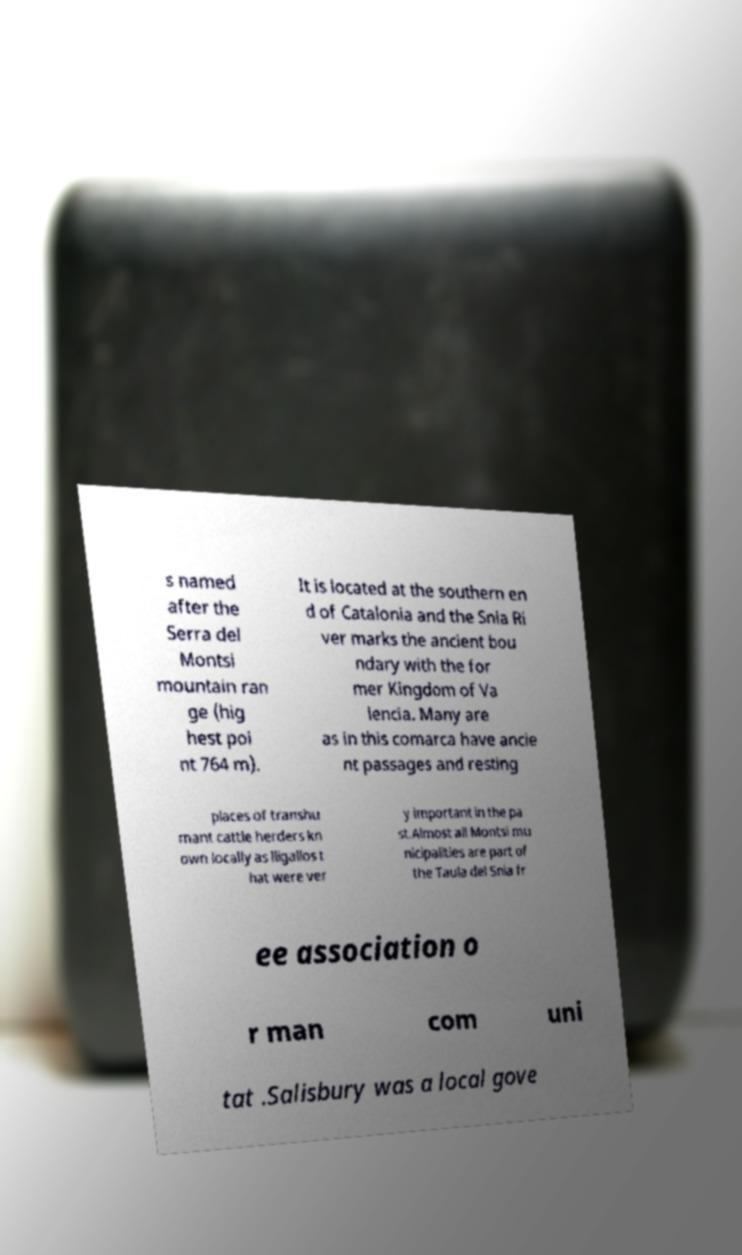Can you read and provide the text displayed in the image?This photo seems to have some interesting text. Can you extract and type it out for me? s named after the Serra del Montsi mountain ran ge (hig hest poi nt 764 m). It is located at the southern en d of Catalonia and the Snia Ri ver marks the ancient bou ndary with the for mer Kingdom of Va lencia. Many are as in this comarca have ancie nt passages and resting places of transhu mant cattle herders kn own locally as lligallos t hat were ver y important in the pa st.Almost all Montsi mu nicipalities are part of the Taula del Snia fr ee association o r man com uni tat .Salisbury was a local gove 